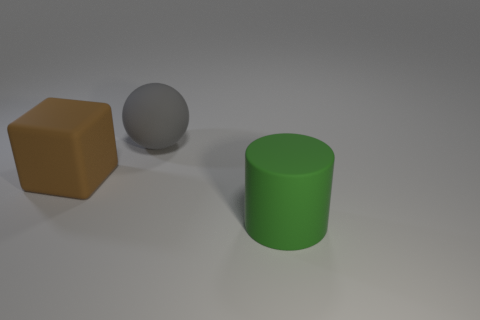Subtract all blue cubes. Subtract all green spheres. How many cubes are left? 1 Add 1 tiny yellow shiny spheres. How many objects exist? 4 Subtract all cylinders. How many objects are left? 2 Add 1 large shiny balls. How many large shiny balls exist? 1 Subtract 0 brown balls. How many objects are left? 3 Subtract all tiny green metallic cylinders. Subtract all big green matte cylinders. How many objects are left? 2 Add 1 green matte objects. How many green matte objects are left? 2 